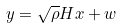<formula> <loc_0><loc_0><loc_500><loc_500>y = \sqrt { \rho } H x + w</formula> 